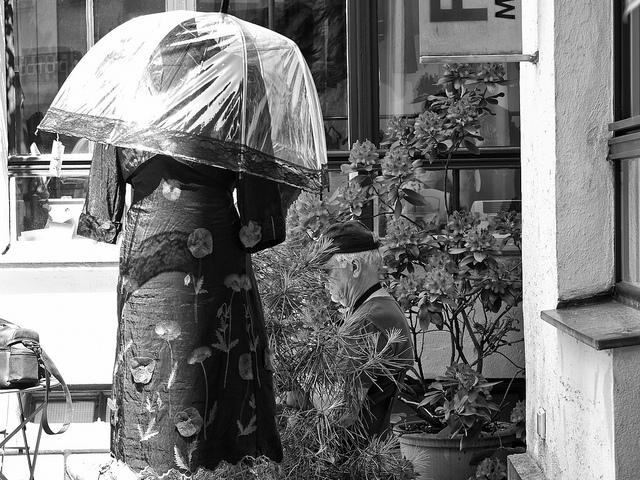Why no hands or head? mannequin 